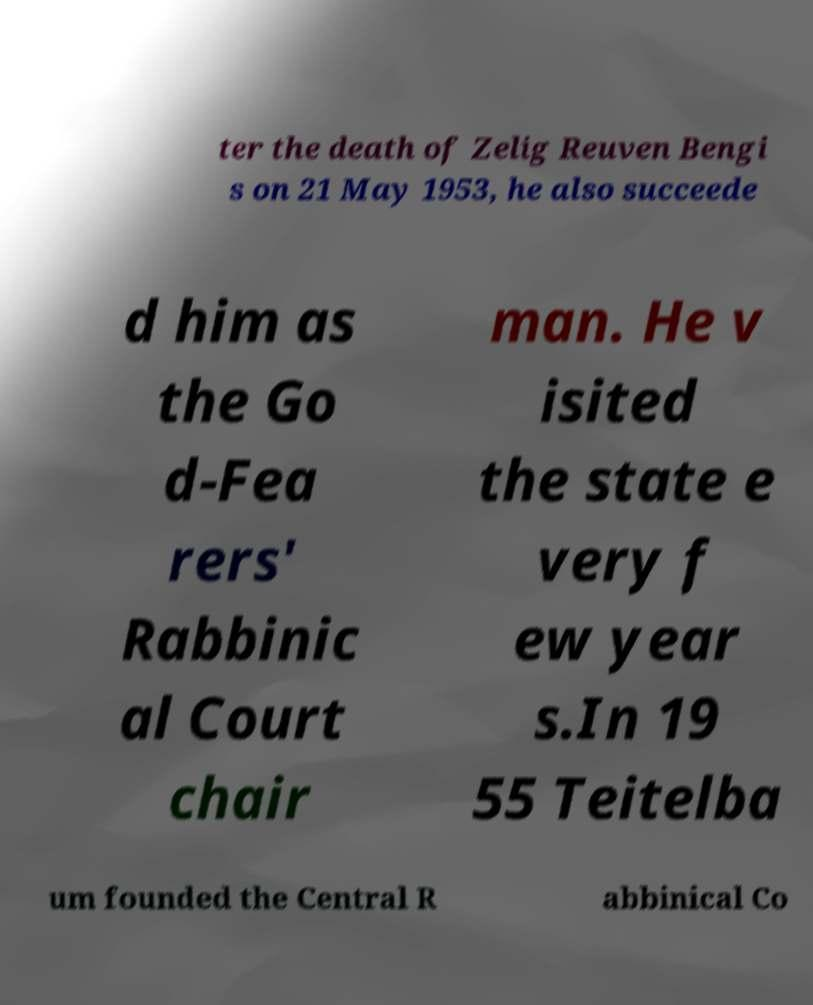There's text embedded in this image that I need extracted. Can you transcribe it verbatim? ter the death of Zelig Reuven Bengi s on 21 May 1953, he also succeede d him as the Go d-Fea rers' Rabbinic al Court chair man. He v isited the state e very f ew year s.In 19 55 Teitelba um founded the Central R abbinical Co 